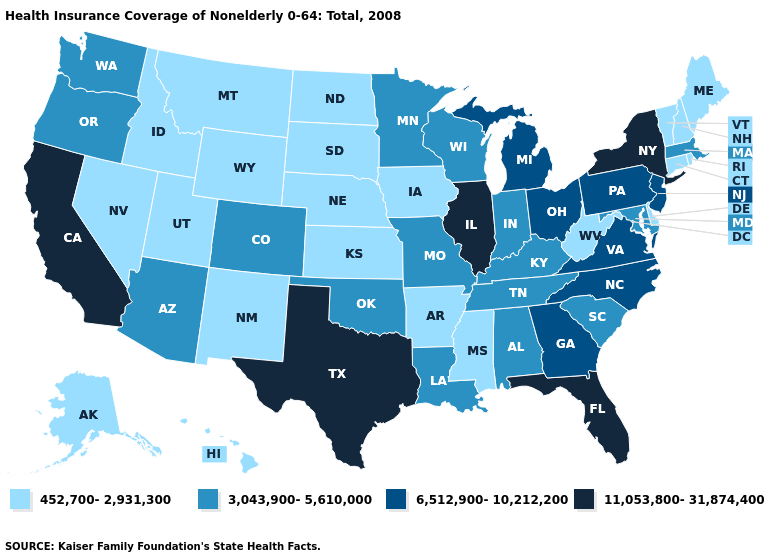Does Florida have a higher value than West Virginia?
Concise answer only. Yes. Name the states that have a value in the range 452,700-2,931,300?
Answer briefly. Alaska, Arkansas, Connecticut, Delaware, Hawaii, Idaho, Iowa, Kansas, Maine, Mississippi, Montana, Nebraska, Nevada, New Hampshire, New Mexico, North Dakota, Rhode Island, South Dakota, Utah, Vermont, West Virginia, Wyoming. Name the states that have a value in the range 452,700-2,931,300?
Be succinct. Alaska, Arkansas, Connecticut, Delaware, Hawaii, Idaho, Iowa, Kansas, Maine, Mississippi, Montana, Nebraska, Nevada, New Hampshire, New Mexico, North Dakota, Rhode Island, South Dakota, Utah, Vermont, West Virginia, Wyoming. What is the value of Virginia?
Give a very brief answer. 6,512,900-10,212,200. What is the value of Maryland?
Be succinct. 3,043,900-5,610,000. Among the states that border Wyoming , which have the lowest value?
Give a very brief answer. Idaho, Montana, Nebraska, South Dakota, Utah. Name the states that have a value in the range 3,043,900-5,610,000?
Write a very short answer. Alabama, Arizona, Colorado, Indiana, Kentucky, Louisiana, Maryland, Massachusetts, Minnesota, Missouri, Oklahoma, Oregon, South Carolina, Tennessee, Washington, Wisconsin. How many symbols are there in the legend?
Short answer required. 4. Among the states that border Virginia , which have the lowest value?
Give a very brief answer. West Virginia. Name the states that have a value in the range 3,043,900-5,610,000?
Quick response, please. Alabama, Arizona, Colorado, Indiana, Kentucky, Louisiana, Maryland, Massachusetts, Minnesota, Missouri, Oklahoma, Oregon, South Carolina, Tennessee, Washington, Wisconsin. Which states have the highest value in the USA?
Write a very short answer. California, Florida, Illinois, New York, Texas. Name the states that have a value in the range 3,043,900-5,610,000?
Keep it brief. Alabama, Arizona, Colorado, Indiana, Kentucky, Louisiana, Maryland, Massachusetts, Minnesota, Missouri, Oklahoma, Oregon, South Carolina, Tennessee, Washington, Wisconsin. Name the states that have a value in the range 3,043,900-5,610,000?
Keep it brief. Alabama, Arizona, Colorado, Indiana, Kentucky, Louisiana, Maryland, Massachusetts, Minnesota, Missouri, Oklahoma, Oregon, South Carolina, Tennessee, Washington, Wisconsin. What is the value of Connecticut?
Quick response, please. 452,700-2,931,300. Among the states that border Kentucky , which have the lowest value?
Write a very short answer. West Virginia. 